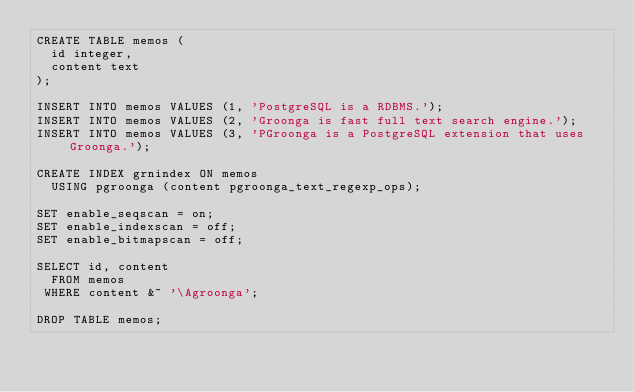<code> <loc_0><loc_0><loc_500><loc_500><_SQL_>CREATE TABLE memos (
  id integer,
  content text
);

INSERT INTO memos VALUES (1, 'PostgreSQL is a RDBMS.');
INSERT INTO memos VALUES (2, 'Groonga is fast full text search engine.');
INSERT INTO memos VALUES (3, 'PGroonga is a PostgreSQL extension that uses Groonga.');

CREATE INDEX grnindex ON memos
  USING pgroonga (content pgroonga_text_regexp_ops);

SET enable_seqscan = on;
SET enable_indexscan = off;
SET enable_bitmapscan = off;

SELECT id, content
  FROM memos
 WHERE content &~ '\Agroonga';

DROP TABLE memos;
</code> 